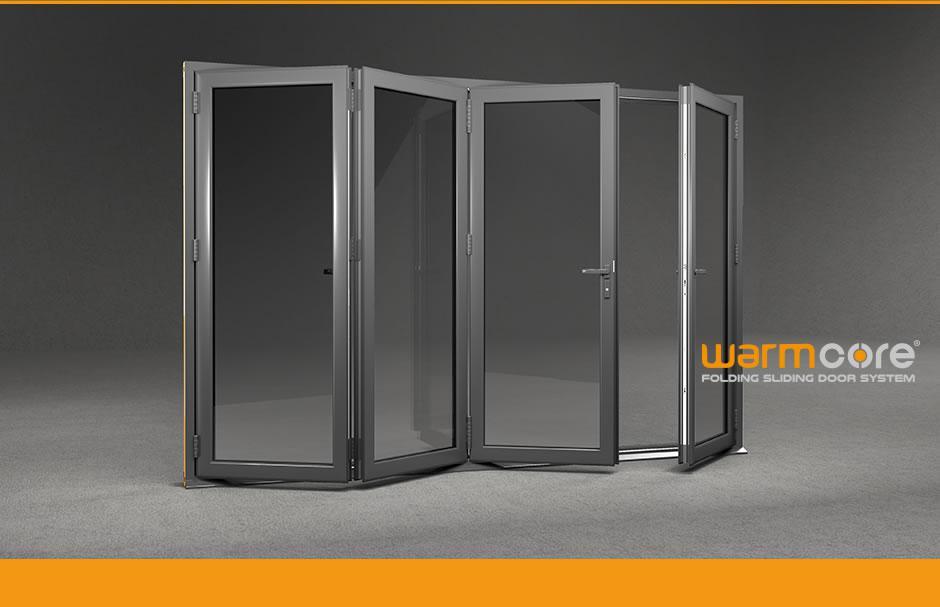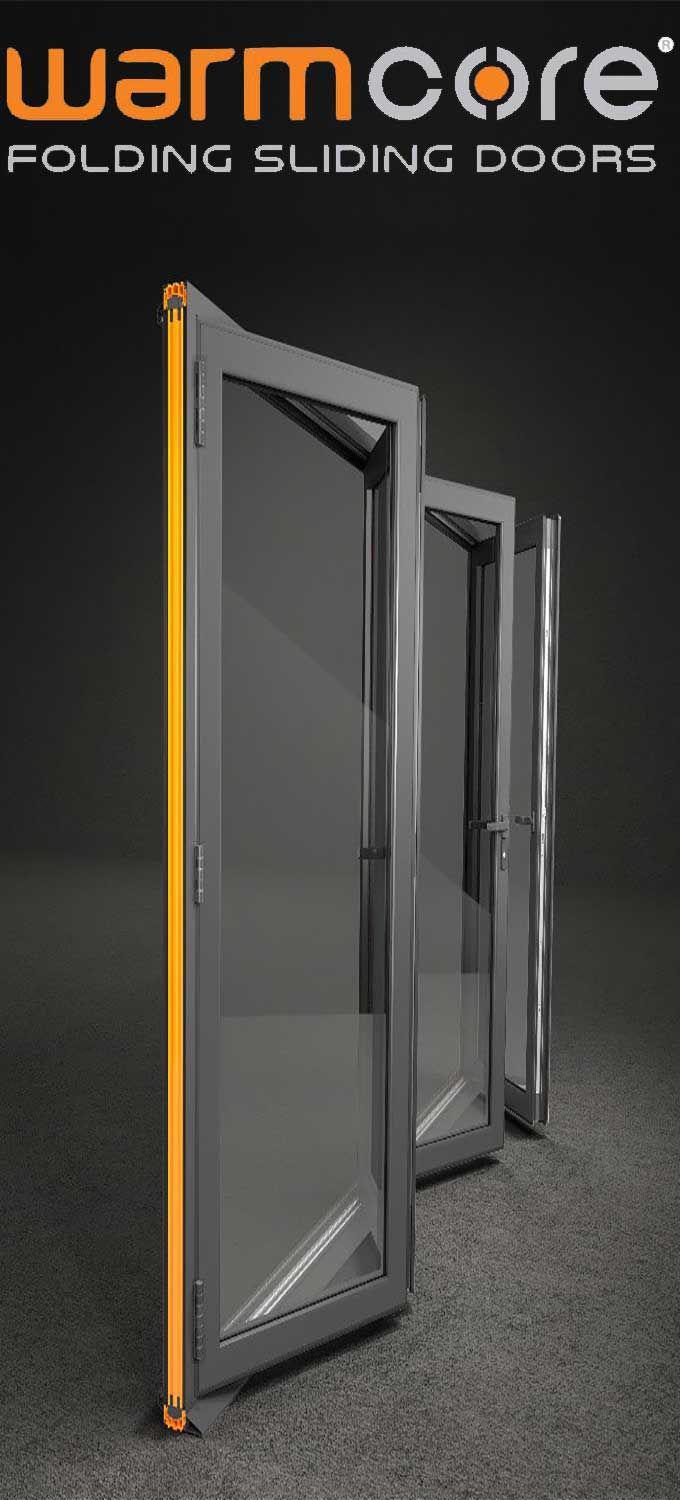The first image is the image on the left, the second image is the image on the right. Examine the images to the left and right. Is the description "An image shows a glass door unit with at least three panels and with a handle on the rightmost door, flanked by bricks of different colors and viewed at an angle." accurate? Answer yes or no. No. The first image is the image on the left, the second image is the image on the right. Assess this claim about the two images: "The doors in the left image are closed.". Correct or not? Answer yes or no. No. 